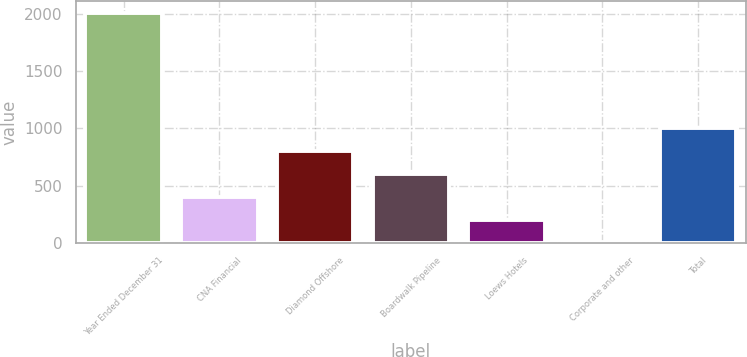Convert chart. <chart><loc_0><loc_0><loc_500><loc_500><bar_chart><fcel>Year Ended December 31<fcel>CNA Financial<fcel>Diamond Offshore<fcel>Boardwalk Pipeline<fcel>Loews Hotels<fcel>Corporate and other<fcel>Total<nl><fcel>2006<fcel>403.6<fcel>804.2<fcel>603.9<fcel>203.3<fcel>3<fcel>1004.5<nl></chart> 